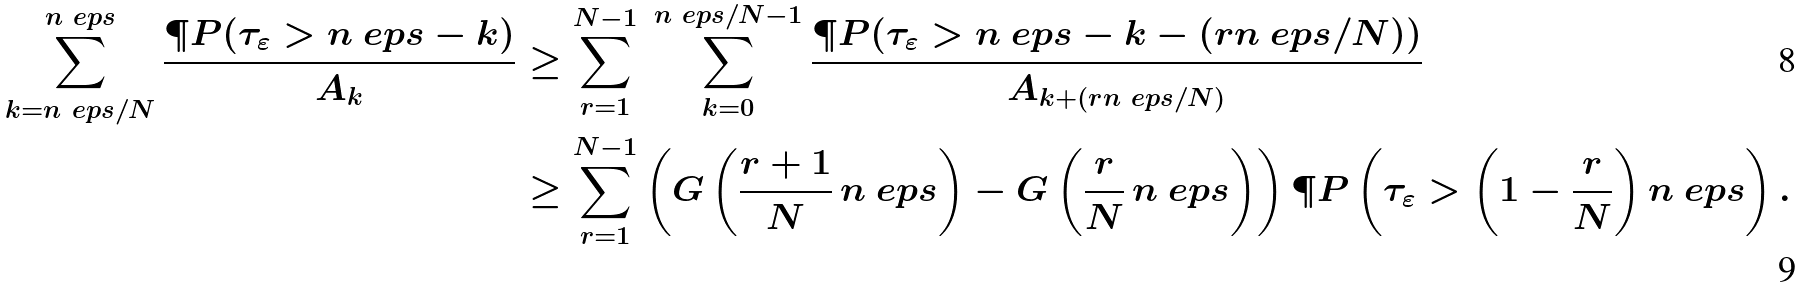<formula> <loc_0><loc_0><loc_500><loc_500>\sum _ { k = n _ { \ } e p s / N } ^ { n _ { \ } e p s } \frac { \P P ( \tau _ { \varepsilon } > { n _ { \ } e p s } - k ) } { A _ { k } } & \geq \sum _ { r = 1 } ^ { N - 1 } \ \sum _ { k = 0 } ^ { { n _ { \ } e p s } / N - 1 } \frac { \P P ( \tau _ { \varepsilon } > { n _ { \ } e p s } - k - ( r { n _ { \ } e p s } / N ) ) } { A _ { k + ( r { n _ { \ } e p s } / N ) } } \\ & \geq \sum _ { r = 1 } ^ { N - 1 } \left ( G \left ( \frac { r + 1 } { N } \, { n _ { \ } e p s } \right ) - G \left ( \frac { r } { N } \, { n _ { \ } e p s } \right ) \right ) \P P \left ( \tau _ { \varepsilon } > \left ( 1 - \frac { r } { N } \right ) { n _ { \ } e p s } \right ) .</formula> 